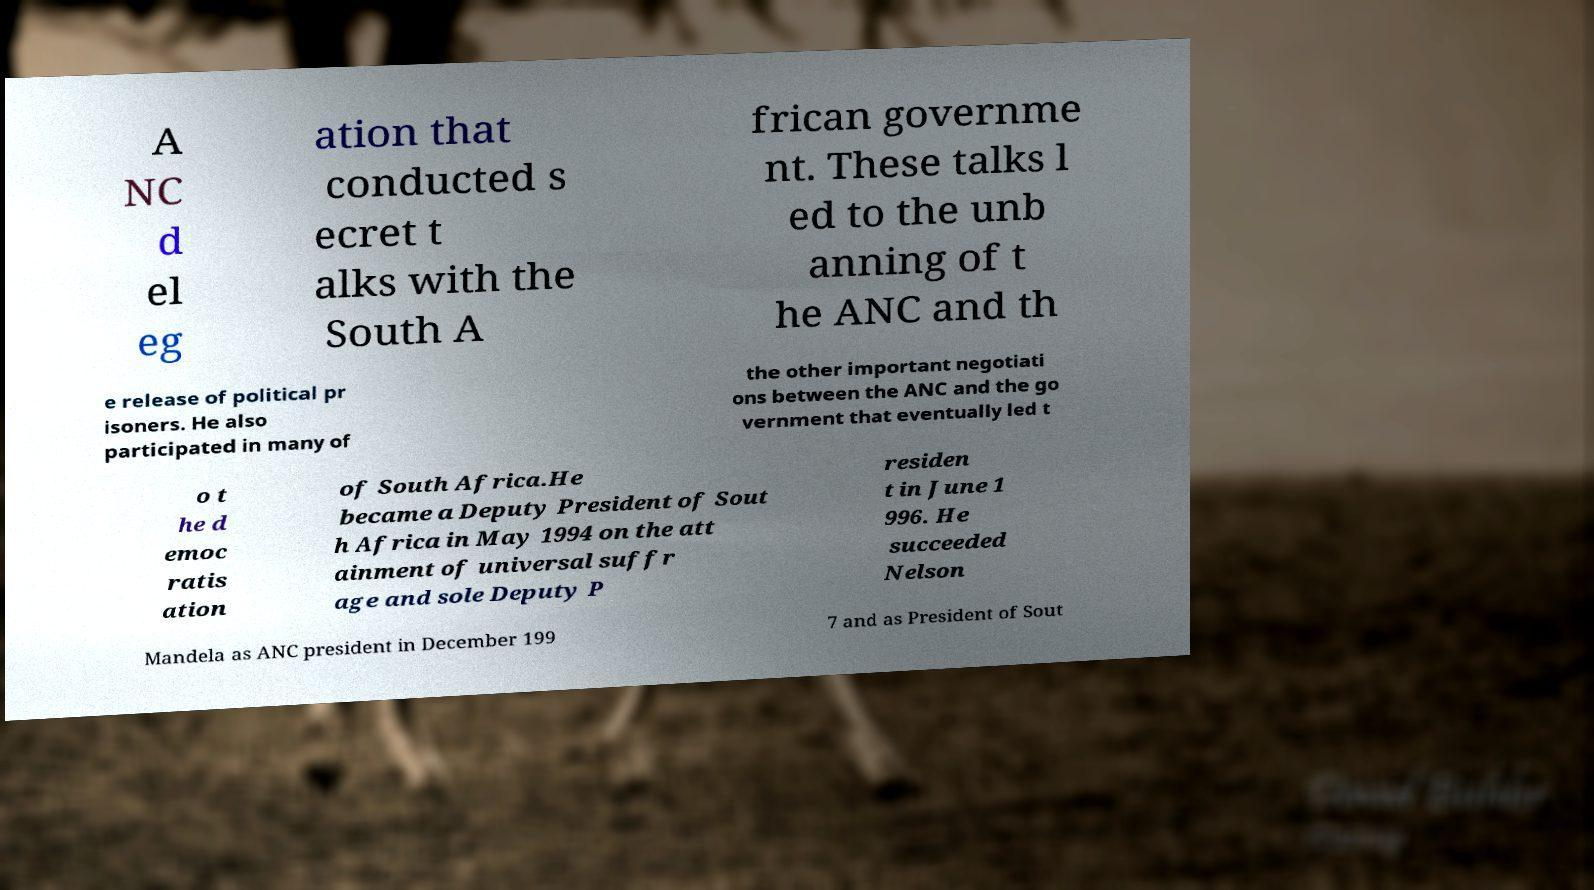Could you extract and type out the text from this image? A NC d el eg ation that conducted s ecret t alks with the South A frican governme nt. These talks l ed to the unb anning of t he ANC and th e release of political pr isoners. He also participated in many of the other important negotiati ons between the ANC and the go vernment that eventually led t o t he d emoc ratis ation of South Africa.He became a Deputy President of Sout h Africa in May 1994 on the att ainment of universal suffr age and sole Deputy P residen t in June 1 996. He succeeded Nelson Mandela as ANC president in December 199 7 and as President of Sout 